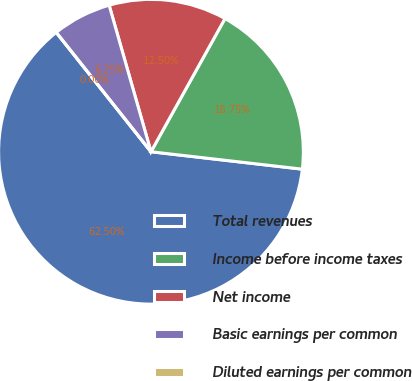Convert chart. <chart><loc_0><loc_0><loc_500><loc_500><pie_chart><fcel>Total revenues<fcel>Income before income taxes<fcel>Net income<fcel>Basic earnings per common<fcel>Diluted earnings per common<nl><fcel>62.5%<fcel>18.75%<fcel>12.5%<fcel>6.25%<fcel>0.0%<nl></chart> 